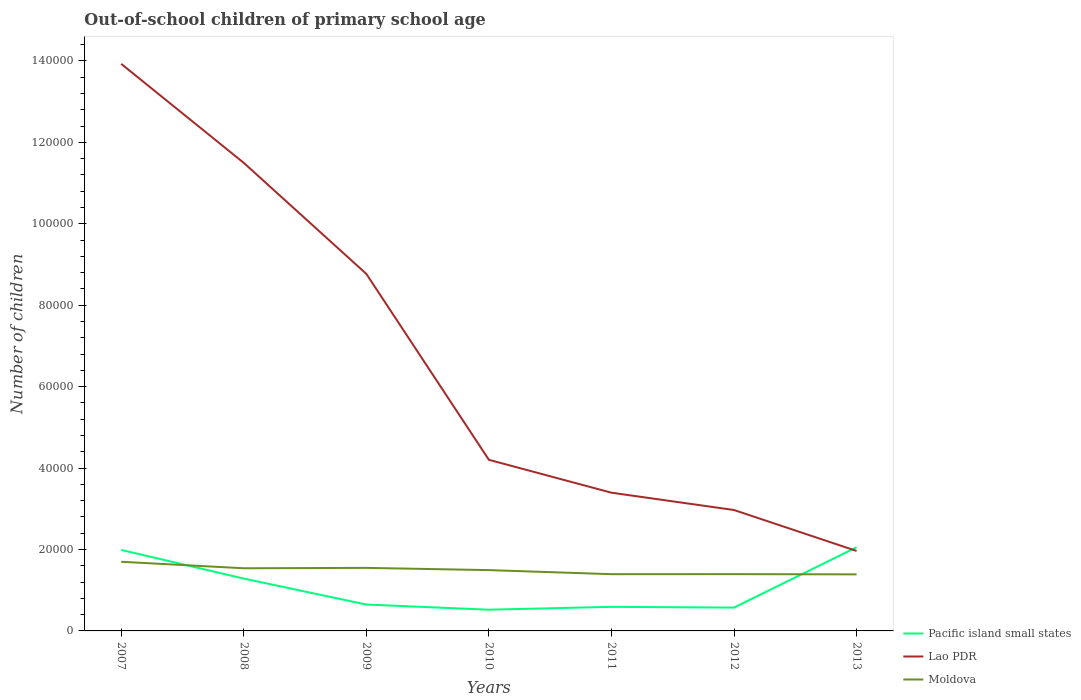How many different coloured lines are there?
Provide a short and direct response. 3. Is the number of lines equal to the number of legend labels?
Keep it short and to the point. Yes. Across all years, what is the maximum number of out-of-school children in Pacific island small states?
Give a very brief answer. 5212. What is the total number of out-of-school children in Lao PDR in the graph?
Give a very brief answer. 5.16e+04. What is the difference between the highest and the second highest number of out-of-school children in Lao PDR?
Provide a succinct answer. 1.20e+05. What is the difference between the highest and the lowest number of out-of-school children in Moldova?
Keep it short and to the point. 3. Is the number of out-of-school children in Pacific island small states strictly greater than the number of out-of-school children in Lao PDR over the years?
Provide a succinct answer. No. How many years are there in the graph?
Give a very brief answer. 7. What is the difference between two consecutive major ticks on the Y-axis?
Make the answer very short. 2.00e+04. How many legend labels are there?
Make the answer very short. 3. What is the title of the graph?
Your answer should be compact. Out-of-school children of primary school age. Does "High income" appear as one of the legend labels in the graph?
Offer a terse response. No. What is the label or title of the X-axis?
Provide a short and direct response. Years. What is the label or title of the Y-axis?
Give a very brief answer. Number of children. What is the Number of children in Pacific island small states in 2007?
Provide a succinct answer. 1.99e+04. What is the Number of children of Lao PDR in 2007?
Ensure brevity in your answer.  1.39e+05. What is the Number of children of Moldova in 2007?
Offer a very short reply. 1.70e+04. What is the Number of children in Pacific island small states in 2008?
Keep it short and to the point. 1.29e+04. What is the Number of children of Lao PDR in 2008?
Ensure brevity in your answer.  1.15e+05. What is the Number of children in Moldova in 2008?
Offer a very short reply. 1.54e+04. What is the Number of children of Pacific island small states in 2009?
Make the answer very short. 6480. What is the Number of children of Lao PDR in 2009?
Your answer should be compact. 8.77e+04. What is the Number of children of Moldova in 2009?
Provide a succinct answer. 1.55e+04. What is the Number of children of Pacific island small states in 2010?
Provide a short and direct response. 5212. What is the Number of children of Lao PDR in 2010?
Offer a very short reply. 4.20e+04. What is the Number of children in Moldova in 2010?
Keep it short and to the point. 1.49e+04. What is the Number of children in Pacific island small states in 2011?
Your answer should be compact. 5916. What is the Number of children in Lao PDR in 2011?
Your answer should be compact. 3.39e+04. What is the Number of children of Moldova in 2011?
Your answer should be compact. 1.39e+04. What is the Number of children of Pacific island small states in 2012?
Make the answer very short. 5727. What is the Number of children of Lao PDR in 2012?
Provide a short and direct response. 2.97e+04. What is the Number of children of Moldova in 2012?
Ensure brevity in your answer.  1.39e+04. What is the Number of children in Pacific island small states in 2013?
Your answer should be very brief. 2.05e+04. What is the Number of children of Lao PDR in 2013?
Your response must be concise. 1.96e+04. What is the Number of children in Moldova in 2013?
Provide a short and direct response. 1.39e+04. Across all years, what is the maximum Number of children in Pacific island small states?
Offer a terse response. 2.05e+04. Across all years, what is the maximum Number of children in Lao PDR?
Make the answer very short. 1.39e+05. Across all years, what is the maximum Number of children of Moldova?
Give a very brief answer. 1.70e+04. Across all years, what is the minimum Number of children of Pacific island small states?
Offer a terse response. 5212. Across all years, what is the minimum Number of children of Lao PDR?
Your answer should be compact. 1.96e+04. Across all years, what is the minimum Number of children in Moldova?
Offer a very short reply. 1.39e+04. What is the total Number of children in Pacific island small states in the graph?
Provide a succinct answer. 7.66e+04. What is the total Number of children of Lao PDR in the graph?
Your response must be concise. 4.67e+05. What is the total Number of children in Moldova in the graph?
Provide a short and direct response. 1.05e+05. What is the difference between the Number of children of Pacific island small states in 2007 and that in 2008?
Provide a succinct answer. 7038. What is the difference between the Number of children in Lao PDR in 2007 and that in 2008?
Give a very brief answer. 2.43e+04. What is the difference between the Number of children in Moldova in 2007 and that in 2008?
Ensure brevity in your answer.  1593. What is the difference between the Number of children of Pacific island small states in 2007 and that in 2009?
Offer a terse response. 1.34e+04. What is the difference between the Number of children in Lao PDR in 2007 and that in 2009?
Make the answer very short. 5.16e+04. What is the difference between the Number of children in Moldova in 2007 and that in 2009?
Your response must be concise. 1500. What is the difference between the Number of children in Pacific island small states in 2007 and that in 2010?
Your response must be concise. 1.47e+04. What is the difference between the Number of children of Lao PDR in 2007 and that in 2010?
Your answer should be compact. 9.72e+04. What is the difference between the Number of children in Moldova in 2007 and that in 2010?
Offer a very short reply. 2046. What is the difference between the Number of children in Pacific island small states in 2007 and that in 2011?
Offer a very short reply. 1.40e+04. What is the difference between the Number of children of Lao PDR in 2007 and that in 2011?
Offer a very short reply. 1.05e+05. What is the difference between the Number of children of Moldova in 2007 and that in 2011?
Ensure brevity in your answer.  3047. What is the difference between the Number of children in Pacific island small states in 2007 and that in 2012?
Provide a short and direct response. 1.42e+04. What is the difference between the Number of children of Lao PDR in 2007 and that in 2012?
Your answer should be very brief. 1.10e+05. What is the difference between the Number of children in Moldova in 2007 and that in 2012?
Your answer should be compact. 3037. What is the difference between the Number of children in Pacific island small states in 2007 and that in 2013?
Ensure brevity in your answer.  -640. What is the difference between the Number of children of Lao PDR in 2007 and that in 2013?
Your response must be concise. 1.20e+05. What is the difference between the Number of children of Moldova in 2007 and that in 2013?
Your response must be concise. 3090. What is the difference between the Number of children in Pacific island small states in 2008 and that in 2009?
Give a very brief answer. 6377. What is the difference between the Number of children of Lao PDR in 2008 and that in 2009?
Your answer should be very brief. 2.73e+04. What is the difference between the Number of children in Moldova in 2008 and that in 2009?
Give a very brief answer. -93. What is the difference between the Number of children in Pacific island small states in 2008 and that in 2010?
Keep it short and to the point. 7645. What is the difference between the Number of children in Lao PDR in 2008 and that in 2010?
Offer a very short reply. 7.29e+04. What is the difference between the Number of children in Moldova in 2008 and that in 2010?
Ensure brevity in your answer.  453. What is the difference between the Number of children in Pacific island small states in 2008 and that in 2011?
Ensure brevity in your answer.  6941. What is the difference between the Number of children of Lao PDR in 2008 and that in 2011?
Give a very brief answer. 8.10e+04. What is the difference between the Number of children in Moldova in 2008 and that in 2011?
Ensure brevity in your answer.  1454. What is the difference between the Number of children in Pacific island small states in 2008 and that in 2012?
Your answer should be compact. 7130. What is the difference between the Number of children of Lao PDR in 2008 and that in 2012?
Your answer should be very brief. 8.53e+04. What is the difference between the Number of children in Moldova in 2008 and that in 2012?
Provide a short and direct response. 1444. What is the difference between the Number of children of Pacific island small states in 2008 and that in 2013?
Give a very brief answer. -7678. What is the difference between the Number of children of Lao PDR in 2008 and that in 2013?
Your answer should be compact. 9.53e+04. What is the difference between the Number of children in Moldova in 2008 and that in 2013?
Your answer should be compact. 1497. What is the difference between the Number of children in Pacific island small states in 2009 and that in 2010?
Provide a short and direct response. 1268. What is the difference between the Number of children of Lao PDR in 2009 and that in 2010?
Your answer should be very brief. 4.57e+04. What is the difference between the Number of children in Moldova in 2009 and that in 2010?
Your answer should be very brief. 546. What is the difference between the Number of children of Pacific island small states in 2009 and that in 2011?
Give a very brief answer. 564. What is the difference between the Number of children of Lao PDR in 2009 and that in 2011?
Offer a very short reply. 5.37e+04. What is the difference between the Number of children of Moldova in 2009 and that in 2011?
Keep it short and to the point. 1547. What is the difference between the Number of children in Pacific island small states in 2009 and that in 2012?
Provide a succinct answer. 753. What is the difference between the Number of children of Lao PDR in 2009 and that in 2012?
Your answer should be very brief. 5.80e+04. What is the difference between the Number of children of Moldova in 2009 and that in 2012?
Make the answer very short. 1537. What is the difference between the Number of children in Pacific island small states in 2009 and that in 2013?
Ensure brevity in your answer.  -1.41e+04. What is the difference between the Number of children in Lao PDR in 2009 and that in 2013?
Ensure brevity in your answer.  6.80e+04. What is the difference between the Number of children of Moldova in 2009 and that in 2013?
Give a very brief answer. 1590. What is the difference between the Number of children in Pacific island small states in 2010 and that in 2011?
Provide a succinct answer. -704. What is the difference between the Number of children in Lao PDR in 2010 and that in 2011?
Give a very brief answer. 8078. What is the difference between the Number of children of Moldova in 2010 and that in 2011?
Offer a terse response. 1001. What is the difference between the Number of children in Pacific island small states in 2010 and that in 2012?
Give a very brief answer. -515. What is the difference between the Number of children of Lao PDR in 2010 and that in 2012?
Your answer should be very brief. 1.23e+04. What is the difference between the Number of children of Moldova in 2010 and that in 2012?
Provide a succinct answer. 991. What is the difference between the Number of children of Pacific island small states in 2010 and that in 2013?
Give a very brief answer. -1.53e+04. What is the difference between the Number of children in Lao PDR in 2010 and that in 2013?
Give a very brief answer. 2.24e+04. What is the difference between the Number of children of Moldova in 2010 and that in 2013?
Give a very brief answer. 1044. What is the difference between the Number of children in Pacific island small states in 2011 and that in 2012?
Your answer should be very brief. 189. What is the difference between the Number of children of Lao PDR in 2011 and that in 2012?
Keep it short and to the point. 4252. What is the difference between the Number of children in Pacific island small states in 2011 and that in 2013?
Provide a succinct answer. -1.46e+04. What is the difference between the Number of children in Lao PDR in 2011 and that in 2013?
Your answer should be compact. 1.43e+04. What is the difference between the Number of children of Moldova in 2011 and that in 2013?
Provide a succinct answer. 43. What is the difference between the Number of children in Pacific island small states in 2012 and that in 2013?
Make the answer very short. -1.48e+04. What is the difference between the Number of children of Lao PDR in 2012 and that in 2013?
Keep it short and to the point. 1.01e+04. What is the difference between the Number of children in Pacific island small states in 2007 and the Number of children in Lao PDR in 2008?
Your response must be concise. -9.51e+04. What is the difference between the Number of children of Pacific island small states in 2007 and the Number of children of Moldova in 2008?
Your answer should be compact. 4506. What is the difference between the Number of children of Lao PDR in 2007 and the Number of children of Moldova in 2008?
Your response must be concise. 1.24e+05. What is the difference between the Number of children in Pacific island small states in 2007 and the Number of children in Lao PDR in 2009?
Your answer should be compact. -6.78e+04. What is the difference between the Number of children in Pacific island small states in 2007 and the Number of children in Moldova in 2009?
Ensure brevity in your answer.  4413. What is the difference between the Number of children in Lao PDR in 2007 and the Number of children in Moldova in 2009?
Make the answer very short. 1.24e+05. What is the difference between the Number of children of Pacific island small states in 2007 and the Number of children of Lao PDR in 2010?
Your answer should be very brief. -2.21e+04. What is the difference between the Number of children in Pacific island small states in 2007 and the Number of children in Moldova in 2010?
Your response must be concise. 4959. What is the difference between the Number of children in Lao PDR in 2007 and the Number of children in Moldova in 2010?
Your answer should be compact. 1.24e+05. What is the difference between the Number of children of Pacific island small states in 2007 and the Number of children of Lao PDR in 2011?
Offer a very short reply. -1.41e+04. What is the difference between the Number of children in Pacific island small states in 2007 and the Number of children in Moldova in 2011?
Make the answer very short. 5960. What is the difference between the Number of children in Lao PDR in 2007 and the Number of children in Moldova in 2011?
Ensure brevity in your answer.  1.25e+05. What is the difference between the Number of children in Pacific island small states in 2007 and the Number of children in Lao PDR in 2012?
Provide a short and direct response. -9799. What is the difference between the Number of children of Pacific island small states in 2007 and the Number of children of Moldova in 2012?
Give a very brief answer. 5950. What is the difference between the Number of children of Lao PDR in 2007 and the Number of children of Moldova in 2012?
Your answer should be compact. 1.25e+05. What is the difference between the Number of children of Pacific island small states in 2007 and the Number of children of Lao PDR in 2013?
Offer a very short reply. 254. What is the difference between the Number of children in Pacific island small states in 2007 and the Number of children in Moldova in 2013?
Your answer should be very brief. 6003. What is the difference between the Number of children in Lao PDR in 2007 and the Number of children in Moldova in 2013?
Offer a terse response. 1.25e+05. What is the difference between the Number of children of Pacific island small states in 2008 and the Number of children of Lao PDR in 2009?
Your response must be concise. -7.48e+04. What is the difference between the Number of children of Pacific island small states in 2008 and the Number of children of Moldova in 2009?
Make the answer very short. -2625. What is the difference between the Number of children of Lao PDR in 2008 and the Number of children of Moldova in 2009?
Give a very brief answer. 9.95e+04. What is the difference between the Number of children of Pacific island small states in 2008 and the Number of children of Lao PDR in 2010?
Provide a succinct answer. -2.92e+04. What is the difference between the Number of children in Pacific island small states in 2008 and the Number of children in Moldova in 2010?
Keep it short and to the point. -2079. What is the difference between the Number of children in Lao PDR in 2008 and the Number of children in Moldova in 2010?
Keep it short and to the point. 1.00e+05. What is the difference between the Number of children of Pacific island small states in 2008 and the Number of children of Lao PDR in 2011?
Your answer should be very brief. -2.11e+04. What is the difference between the Number of children of Pacific island small states in 2008 and the Number of children of Moldova in 2011?
Your answer should be very brief. -1078. What is the difference between the Number of children of Lao PDR in 2008 and the Number of children of Moldova in 2011?
Give a very brief answer. 1.01e+05. What is the difference between the Number of children of Pacific island small states in 2008 and the Number of children of Lao PDR in 2012?
Your answer should be very brief. -1.68e+04. What is the difference between the Number of children of Pacific island small states in 2008 and the Number of children of Moldova in 2012?
Give a very brief answer. -1088. What is the difference between the Number of children of Lao PDR in 2008 and the Number of children of Moldova in 2012?
Provide a short and direct response. 1.01e+05. What is the difference between the Number of children in Pacific island small states in 2008 and the Number of children in Lao PDR in 2013?
Give a very brief answer. -6784. What is the difference between the Number of children of Pacific island small states in 2008 and the Number of children of Moldova in 2013?
Make the answer very short. -1035. What is the difference between the Number of children in Lao PDR in 2008 and the Number of children in Moldova in 2013?
Make the answer very short. 1.01e+05. What is the difference between the Number of children in Pacific island small states in 2009 and the Number of children in Lao PDR in 2010?
Your response must be concise. -3.55e+04. What is the difference between the Number of children of Pacific island small states in 2009 and the Number of children of Moldova in 2010?
Make the answer very short. -8456. What is the difference between the Number of children of Lao PDR in 2009 and the Number of children of Moldova in 2010?
Provide a succinct answer. 7.28e+04. What is the difference between the Number of children of Pacific island small states in 2009 and the Number of children of Lao PDR in 2011?
Make the answer very short. -2.75e+04. What is the difference between the Number of children of Pacific island small states in 2009 and the Number of children of Moldova in 2011?
Offer a terse response. -7455. What is the difference between the Number of children in Lao PDR in 2009 and the Number of children in Moldova in 2011?
Offer a very short reply. 7.38e+04. What is the difference between the Number of children of Pacific island small states in 2009 and the Number of children of Lao PDR in 2012?
Keep it short and to the point. -2.32e+04. What is the difference between the Number of children in Pacific island small states in 2009 and the Number of children in Moldova in 2012?
Offer a terse response. -7465. What is the difference between the Number of children in Lao PDR in 2009 and the Number of children in Moldova in 2012?
Make the answer very short. 7.37e+04. What is the difference between the Number of children of Pacific island small states in 2009 and the Number of children of Lao PDR in 2013?
Your answer should be very brief. -1.32e+04. What is the difference between the Number of children in Pacific island small states in 2009 and the Number of children in Moldova in 2013?
Your answer should be very brief. -7412. What is the difference between the Number of children of Lao PDR in 2009 and the Number of children of Moldova in 2013?
Offer a very short reply. 7.38e+04. What is the difference between the Number of children in Pacific island small states in 2010 and the Number of children in Lao PDR in 2011?
Give a very brief answer. -2.87e+04. What is the difference between the Number of children in Pacific island small states in 2010 and the Number of children in Moldova in 2011?
Offer a terse response. -8723. What is the difference between the Number of children in Lao PDR in 2010 and the Number of children in Moldova in 2011?
Offer a very short reply. 2.81e+04. What is the difference between the Number of children in Pacific island small states in 2010 and the Number of children in Lao PDR in 2012?
Your response must be concise. -2.45e+04. What is the difference between the Number of children in Pacific island small states in 2010 and the Number of children in Moldova in 2012?
Your answer should be very brief. -8733. What is the difference between the Number of children in Lao PDR in 2010 and the Number of children in Moldova in 2012?
Your answer should be compact. 2.81e+04. What is the difference between the Number of children of Pacific island small states in 2010 and the Number of children of Lao PDR in 2013?
Keep it short and to the point. -1.44e+04. What is the difference between the Number of children of Pacific island small states in 2010 and the Number of children of Moldova in 2013?
Give a very brief answer. -8680. What is the difference between the Number of children in Lao PDR in 2010 and the Number of children in Moldova in 2013?
Give a very brief answer. 2.81e+04. What is the difference between the Number of children in Pacific island small states in 2011 and the Number of children in Lao PDR in 2012?
Provide a short and direct response. -2.38e+04. What is the difference between the Number of children of Pacific island small states in 2011 and the Number of children of Moldova in 2012?
Make the answer very short. -8029. What is the difference between the Number of children in Lao PDR in 2011 and the Number of children in Moldova in 2012?
Provide a succinct answer. 2.00e+04. What is the difference between the Number of children of Pacific island small states in 2011 and the Number of children of Lao PDR in 2013?
Ensure brevity in your answer.  -1.37e+04. What is the difference between the Number of children of Pacific island small states in 2011 and the Number of children of Moldova in 2013?
Offer a terse response. -7976. What is the difference between the Number of children of Lao PDR in 2011 and the Number of children of Moldova in 2013?
Offer a terse response. 2.01e+04. What is the difference between the Number of children in Pacific island small states in 2012 and the Number of children in Lao PDR in 2013?
Your answer should be very brief. -1.39e+04. What is the difference between the Number of children of Pacific island small states in 2012 and the Number of children of Moldova in 2013?
Give a very brief answer. -8165. What is the difference between the Number of children of Lao PDR in 2012 and the Number of children of Moldova in 2013?
Give a very brief answer. 1.58e+04. What is the average Number of children of Pacific island small states per year?
Make the answer very short. 1.09e+04. What is the average Number of children in Lao PDR per year?
Make the answer very short. 6.67e+04. What is the average Number of children of Moldova per year?
Provide a short and direct response. 1.49e+04. In the year 2007, what is the difference between the Number of children in Pacific island small states and Number of children in Lao PDR?
Your answer should be very brief. -1.19e+05. In the year 2007, what is the difference between the Number of children in Pacific island small states and Number of children in Moldova?
Give a very brief answer. 2913. In the year 2007, what is the difference between the Number of children in Lao PDR and Number of children in Moldova?
Keep it short and to the point. 1.22e+05. In the year 2008, what is the difference between the Number of children in Pacific island small states and Number of children in Lao PDR?
Make the answer very short. -1.02e+05. In the year 2008, what is the difference between the Number of children in Pacific island small states and Number of children in Moldova?
Provide a succinct answer. -2532. In the year 2008, what is the difference between the Number of children in Lao PDR and Number of children in Moldova?
Make the answer very short. 9.96e+04. In the year 2009, what is the difference between the Number of children of Pacific island small states and Number of children of Lao PDR?
Your answer should be very brief. -8.12e+04. In the year 2009, what is the difference between the Number of children of Pacific island small states and Number of children of Moldova?
Offer a very short reply. -9002. In the year 2009, what is the difference between the Number of children in Lao PDR and Number of children in Moldova?
Offer a terse response. 7.22e+04. In the year 2010, what is the difference between the Number of children in Pacific island small states and Number of children in Lao PDR?
Make the answer very short. -3.68e+04. In the year 2010, what is the difference between the Number of children in Pacific island small states and Number of children in Moldova?
Make the answer very short. -9724. In the year 2010, what is the difference between the Number of children of Lao PDR and Number of children of Moldova?
Offer a terse response. 2.71e+04. In the year 2011, what is the difference between the Number of children in Pacific island small states and Number of children in Lao PDR?
Keep it short and to the point. -2.80e+04. In the year 2011, what is the difference between the Number of children of Pacific island small states and Number of children of Moldova?
Your answer should be very brief. -8019. In the year 2011, what is the difference between the Number of children in Lao PDR and Number of children in Moldova?
Give a very brief answer. 2.00e+04. In the year 2012, what is the difference between the Number of children in Pacific island small states and Number of children in Lao PDR?
Your answer should be very brief. -2.40e+04. In the year 2012, what is the difference between the Number of children of Pacific island small states and Number of children of Moldova?
Provide a succinct answer. -8218. In the year 2012, what is the difference between the Number of children in Lao PDR and Number of children in Moldova?
Provide a short and direct response. 1.57e+04. In the year 2013, what is the difference between the Number of children in Pacific island small states and Number of children in Lao PDR?
Provide a succinct answer. 894. In the year 2013, what is the difference between the Number of children of Pacific island small states and Number of children of Moldova?
Provide a short and direct response. 6643. In the year 2013, what is the difference between the Number of children of Lao PDR and Number of children of Moldova?
Provide a short and direct response. 5749. What is the ratio of the Number of children of Pacific island small states in 2007 to that in 2008?
Provide a short and direct response. 1.55. What is the ratio of the Number of children in Lao PDR in 2007 to that in 2008?
Ensure brevity in your answer.  1.21. What is the ratio of the Number of children in Moldova in 2007 to that in 2008?
Make the answer very short. 1.1. What is the ratio of the Number of children of Pacific island small states in 2007 to that in 2009?
Make the answer very short. 3.07. What is the ratio of the Number of children in Lao PDR in 2007 to that in 2009?
Offer a very short reply. 1.59. What is the ratio of the Number of children in Moldova in 2007 to that in 2009?
Ensure brevity in your answer.  1.1. What is the ratio of the Number of children in Pacific island small states in 2007 to that in 2010?
Ensure brevity in your answer.  3.82. What is the ratio of the Number of children in Lao PDR in 2007 to that in 2010?
Keep it short and to the point. 3.31. What is the ratio of the Number of children of Moldova in 2007 to that in 2010?
Your answer should be very brief. 1.14. What is the ratio of the Number of children in Pacific island small states in 2007 to that in 2011?
Ensure brevity in your answer.  3.36. What is the ratio of the Number of children of Lao PDR in 2007 to that in 2011?
Your answer should be very brief. 4.1. What is the ratio of the Number of children of Moldova in 2007 to that in 2011?
Offer a very short reply. 1.22. What is the ratio of the Number of children of Pacific island small states in 2007 to that in 2012?
Offer a very short reply. 3.47. What is the ratio of the Number of children in Lao PDR in 2007 to that in 2012?
Offer a very short reply. 4.69. What is the ratio of the Number of children of Moldova in 2007 to that in 2012?
Give a very brief answer. 1.22. What is the ratio of the Number of children in Pacific island small states in 2007 to that in 2013?
Make the answer very short. 0.97. What is the ratio of the Number of children in Lao PDR in 2007 to that in 2013?
Make the answer very short. 7.09. What is the ratio of the Number of children in Moldova in 2007 to that in 2013?
Provide a short and direct response. 1.22. What is the ratio of the Number of children of Pacific island small states in 2008 to that in 2009?
Give a very brief answer. 1.98. What is the ratio of the Number of children of Lao PDR in 2008 to that in 2009?
Your response must be concise. 1.31. What is the ratio of the Number of children of Pacific island small states in 2008 to that in 2010?
Ensure brevity in your answer.  2.47. What is the ratio of the Number of children in Lao PDR in 2008 to that in 2010?
Provide a succinct answer. 2.74. What is the ratio of the Number of children in Moldova in 2008 to that in 2010?
Keep it short and to the point. 1.03. What is the ratio of the Number of children of Pacific island small states in 2008 to that in 2011?
Your answer should be very brief. 2.17. What is the ratio of the Number of children of Lao PDR in 2008 to that in 2011?
Provide a succinct answer. 3.39. What is the ratio of the Number of children of Moldova in 2008 to that in 2011?
Make the answer very short. 1.1. What is the ratio of the Number of children in Pacific island small states in 2008 to that in 2012?
Offer a terse response. 2.25. What is the ratio of the Number of children of Lao PDR in 2008 to that in 2012?
Your answer should be compact. 3.87. What is the ratio of the Number of children in Moldova in 2008 to that in 2012?
Offer a very short reply. 1.1. What is the ratio of the Number of children in Pacific island small states in 2008 to that in 2013?
Make the answer very short. 0.63. What is the ratio of the Number of children in Lao PDR in 2008 to that in 2013?
Your answer should be compact. 5.85. What is the ratio of the Number of children of Moldova in 2008 to that in 2013?
Ensure brevity in your answer.  1.11. What is the ratio of the Number of children in Pacific island small states in 2009 to that in 2010?
Your answer should be compact. 1.24. What is the ratio of the Number of children in Lao PDR in 2009 to that in 2010?
Provide a short and direct response. 2.09. What is the ratio of the Number of children of Moldova in 2009 to that in 2010?
Offer a terse response. 1.04. What is the ratio of the Number of children of Pacific island small states in 2009 to that in 2011?
Provide a short and direct response. 1.1. What is the ratio of the Number of children of Lao PDR in 2009 to that in 2011?
Keep it short and to the point. 2.58. What is the ratio of the Number of children of Moldova in 2009 to that in 2011?
Your response must be concise. 1.11. What is the ratio of the Number of children in Pacific island small states in 2009 to that in 2012?
Offer a very short reply. 1.13. What is the ratio of the Number of children in Lao PDR in 2009 to that in 2012?
Your answer should be compact. 2.95. What is the ratio of the Number of children in Moldova in 2009 to that in 2012?
Your answer should be compact. 1.11. What is the ratio of the Number of children in Pacific island small states in 2009 to that in 2013?
Your answer should be compact. 0.32. What is the ratio of the Number of children of Lao PDR in 2009 to that in 2013?
Keep it short and to the point. 4.46. What is the ratio of the Number of children in Moldova in 2009 to that in 2013?
Keep it short and to the point. 1.11. What is the ratio of the Number of children in Pacific island small states in 2010 to that in 2011?
Offer a terse response. 0.88. What is the ratio of the Number of children of Lao PDR in 2010 to that in 2011?
Your answer should be very brief. 1.24. What is the ratio of the Number of children in Moldova in 2010 to that in 2011?
Offer a very short reply. 1.07. What is the ratio of the Number of children in Pacific island small states in 2010 to that in 2012?
Provide a succinct answer. 0.91. What is the ratio of the Number of children in Lao PDR in 2010 to that in 2012?
Your answer should be very brief. 1.42. What is the ratio of the Number of children in Moldova in 2010 to that in 2012?
Offer a very short reply. 1.07. What is the ratio of the Number of children of Pacific island small states in 2010 to that in 2013?
Give a very brief answer. 0.25. What is the ratio of the Number of children in Lao PDR in 2010 to that in 2013?
Make the answer very short. 2.14. What is the ratio of the Number of children in Moldova in 2010 to that in 2013?
Your response must be concise. 1.08. What is the ratio of the Number of children in Pacific island small states in 2011 to that in 2012?
Provide a short and direct response. 1.03. What is the ratio of the Number of children in Lao PDR in 2011 to that in 2012?
Give a very brief answer. 1.14. What is the ratio of the Number of children in Pacific island small states in 2011 to that in 2013?
Your answer should be very brief. 0.29. What is the ratio of the Number of children of Lao PDR in 2011 to that in 2013?
Offer a very short reply. 1.73. What is the ratio of the Number of children in Pacific island small states in 2012 to that in 2013?
Your response must be concise. 0.28. What is the ratio of the Number of children of Lao PDR in 2012 to that in 2013?
Offer a very short reply. 1.51. What is the ratio of the Number of children in Moldova in 2012 to that in 2013?
Offer a very short reply. 1. What is the difference between the highest and the second highest Number of children in Pacific island small states?
Keep it short and to the point. 640. What is the difference between the highest and the second highest Number of children of Lao PDR?
Your answer should be compact. 2.43e+04. What is the difference between the highest and the second highest Number of children of Moldova?
Provide a succinct answer. 1500. What is the difference between the highest and the lowest Number of children in Pacific island small states?
Your answer should be very brief. 1.53e+04. What is the difference between the highest and the lowest Number of children in Lao PDR?
Provide a succinct answer. 1.20e+05. What is the difference between the highest and the lowest Number of children in Moldova?
Ensure brevity in your answer.  3090. 